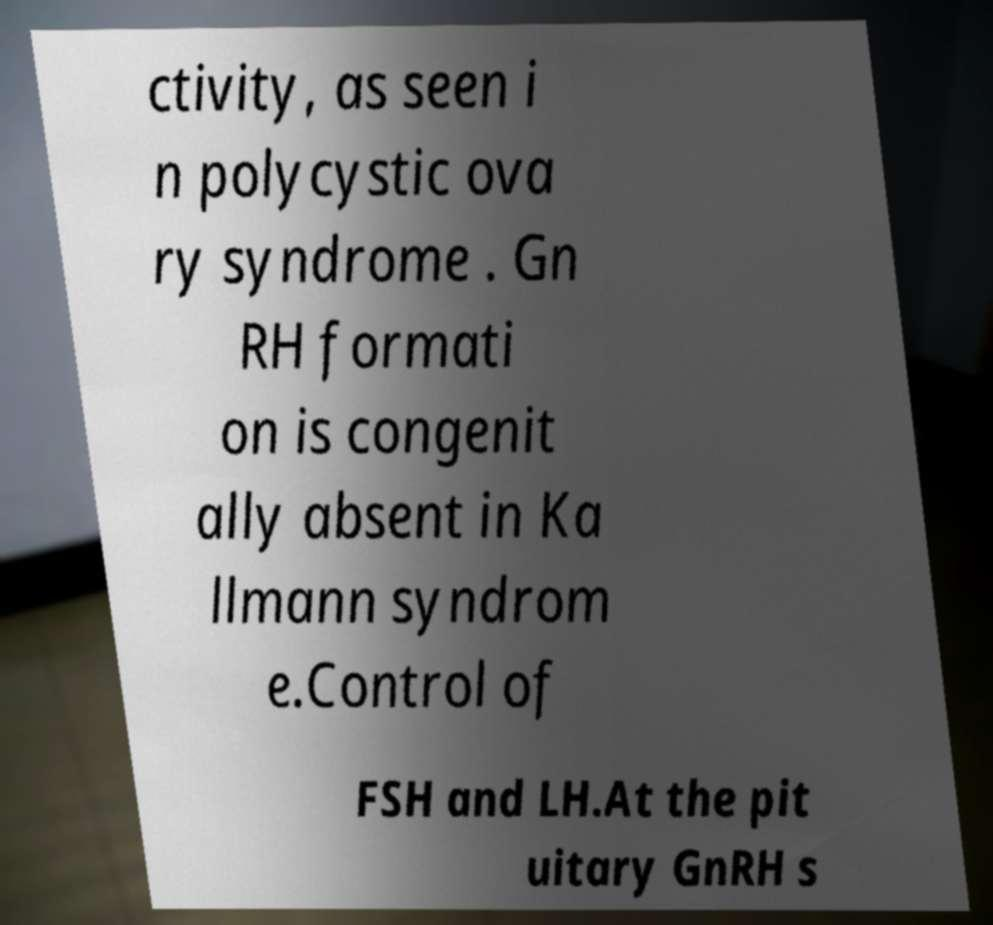For documentation purposes, I need the text within this image transcribed. Could you provide that? ctivity, as seen i n polycystic ova ry syndrome . Gn RH formati on is congenit ally absent in Ka llmann syndrom e.Control of FSH and LH.At the pit uitary GnRH s 